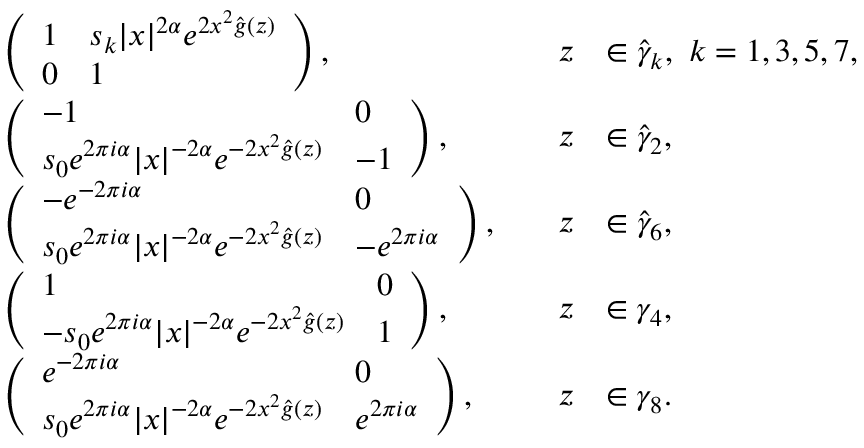<formula> <loc_0><loc_0><loc_500><loc_500>\begin{array} { r l r l } & { \left ( \begin{array} { l l } { 1 } & { s _ { k } | x | ^ { 2 \alpha } e ^ { 2 x ^ { 2 } \widehat { g } ( z ) } } \\ { 0 } & { 1 } \end{array} \right ) , \quad } & { z } & { \in \widehat { \gamma } _ { k } , \ k = 1 , 3 , 5 , 7 , } \\ & { \left ( \begin{array} { l l } { - 1 } & { 0 } \\ { s _ { 0 } e ^ { 2 \pi i \alpha } | x | ^ { - 2 \alpha } e ^ { - 2 x ^ { 2 } \widehat { g } ( z ) } } & { - 1 } \end{array} \right ) , \quad } & { z } & { \in \widehat { \gamma } _ { 2 } , } \\ & { \left ( \begin{array} { l l } { - e ^ { - 2 \pi i \alpha } } & { 0 } \\ { s _ { 0 } e ^ { 2 \pi i \alpha } | x | ^ { - 2 \alpha } e ^ { - 2 x ^ { 2 } \widehat { g } ( z ) } } & { - e ^ { 2 \pi i \alpha } } \end{array} \right ) , \quad } & { z } & { \in \widehat { \gamma } _ { 6 } , } \\ & { \left ( \begin{array} { l l } { 1 } & { 0 } \\ { - s _ { 0 } e ^ { 2 \pi i \alpha } | x | ^ { - 2 \alpha } e ^ { - 2 x ^ { 2 } \widehat { g } ( z ) } } & { 1 } \end{array} \right ) , \quad } & { z } & { \in \gamma _ { 4 } , } \\ & { \left ( \begin{array} { l l } { e ^ { - 2 \pi i \alpha } } & { 0 } \\ { s _ { 0 } e ^ { 2 \pi i \alpha } | x | ^ { - 2 \alpha } e ^ { - 2 x ^ { 2 } \widehat { g } ( z ) } } & { e ^ { 2 \pi i \alpha } } \end{array} \right ) , \quad } & { z } & { \in \gamma _ { 8 } . } \end{array}</formula> 